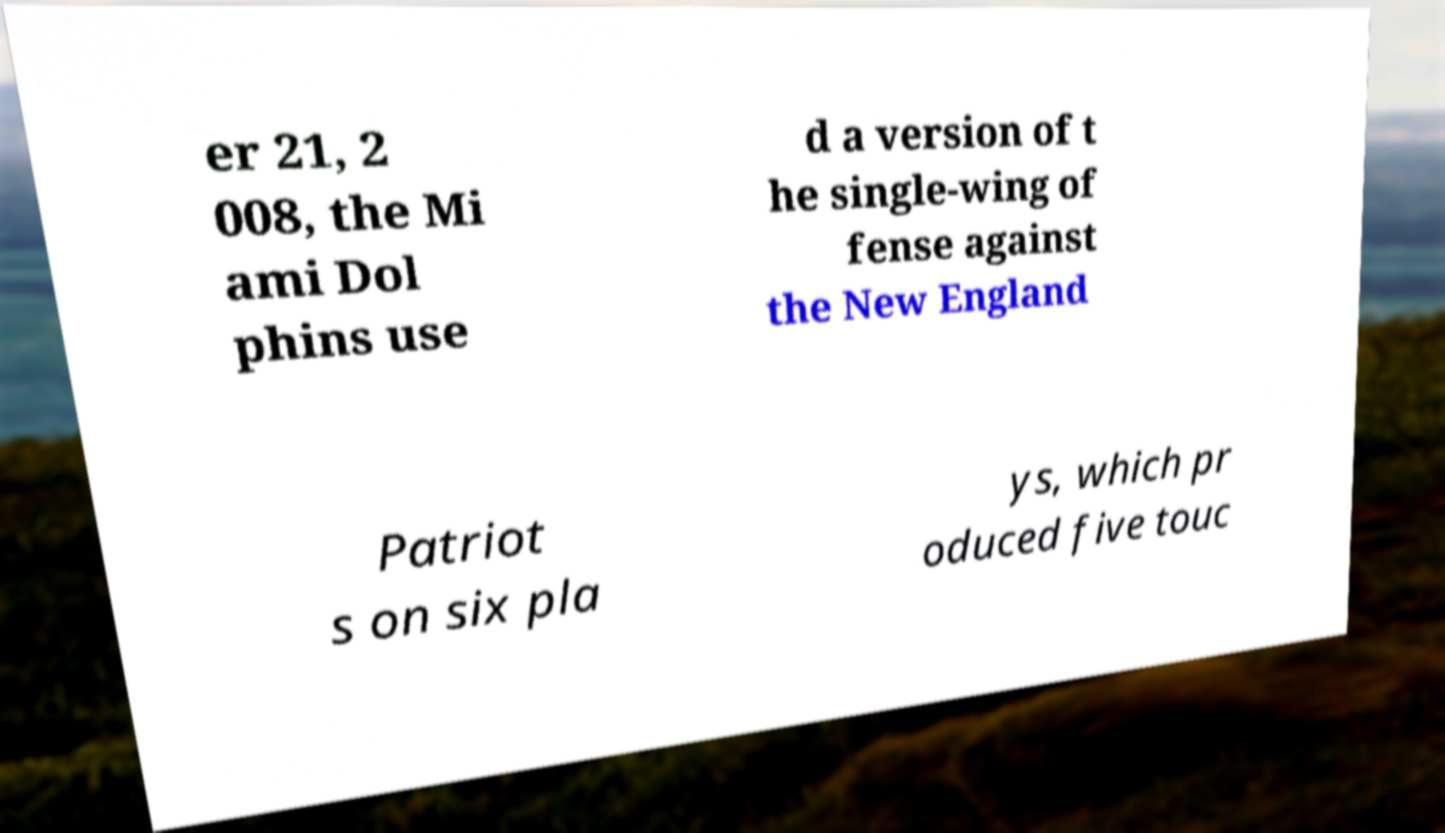For documentation purposes, I need the text within this image transcribed. Could you provide that? er 21, 2 008, the Mi ami Dol phins use d a version of t he single-wing of fense against the New England Patriot s on six pla ys, which pr oduced five touc 